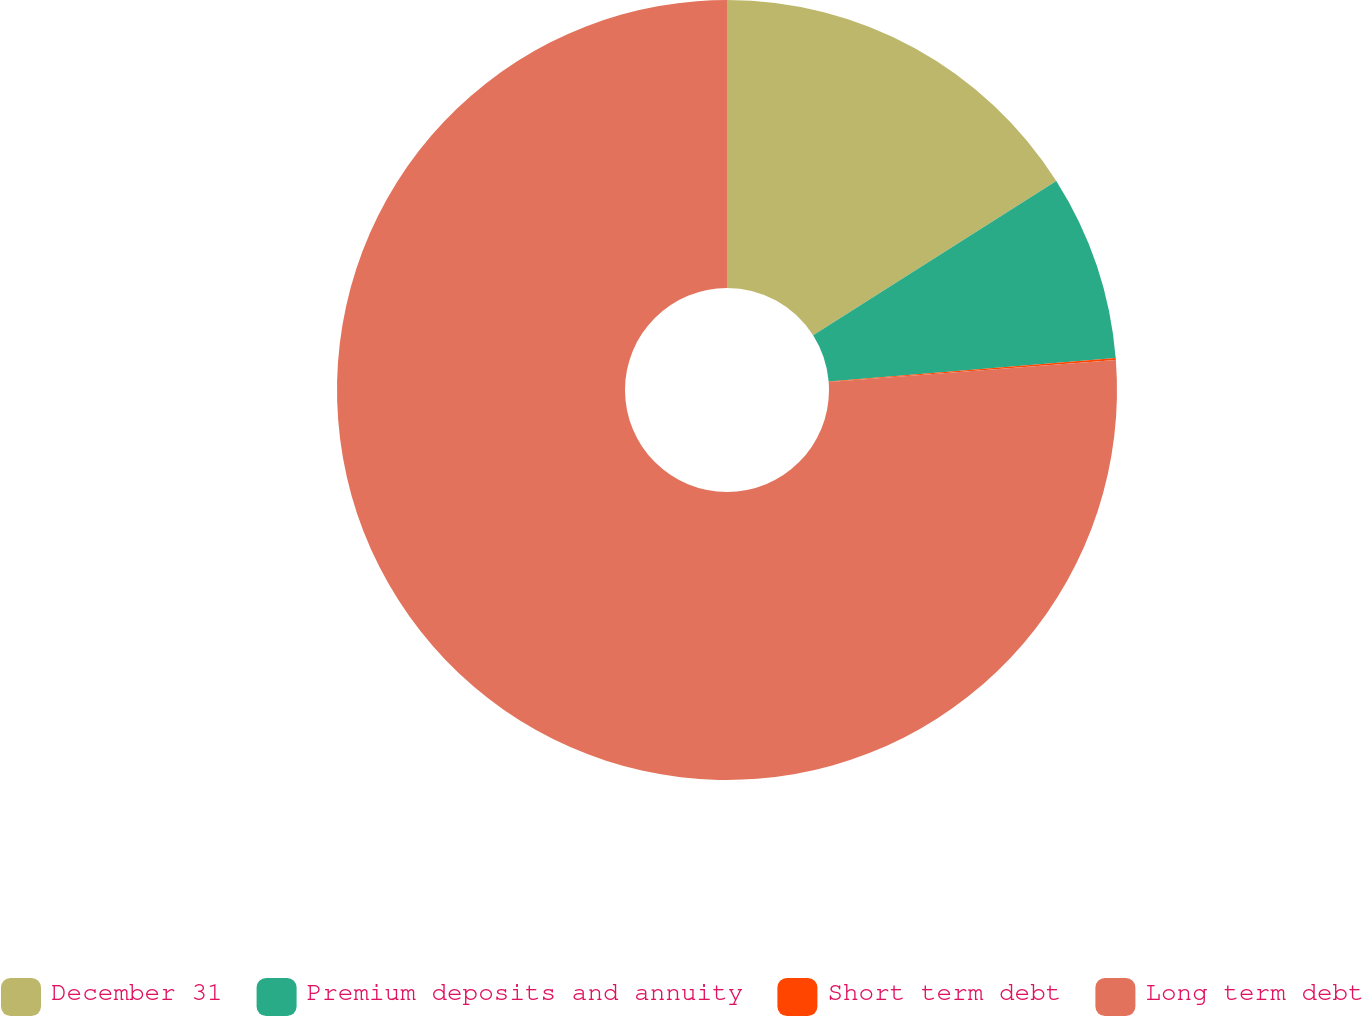Convert chart. <chart><loc_0><loc_0><loc_500><loc_500><pie_chart><fcel>December 31<fcel>Premium deposits and annuity<fcel>Short term debt<fcel>Long term debt<nl><fcel>16.0%<fcel>7.69%<fcel>0.08%<fcel>76.23%<nl></chart> 